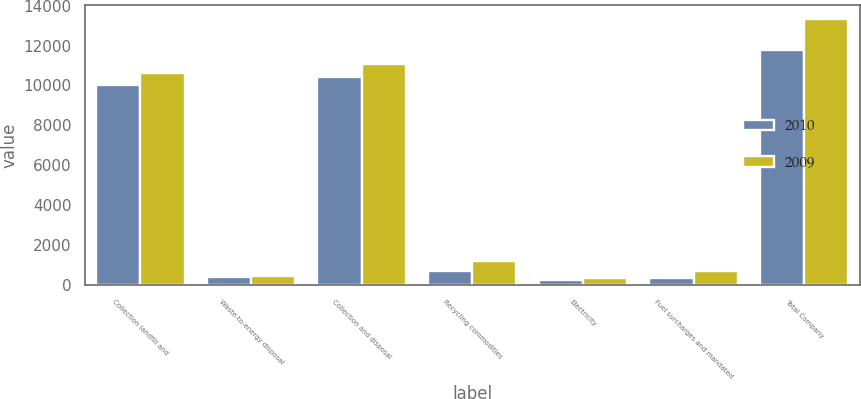Convert chart. <chart><loc_0><loc_0><loc_500><loc_500><stacked_bar_chart><ecel><fcel>Collection landfill and<fcel>Waste-to-energy disposal<fcel>Collection and disposal<fcel>Recycling commodities<fcel>Electricity<fcel>Fuel surcharges and mandated<fcel>Total Company<nl><fcel>2010<fcel>9999<fcel>413<fcel>10412<fcel>723<fcel>279<fcel>375<fcel>11789<nl><fcel>2009<fcel>10622<fcel>434<fcel>11056<fcel>1233<fcel>356<fcel>706<fcel>13351<nl></chart> 